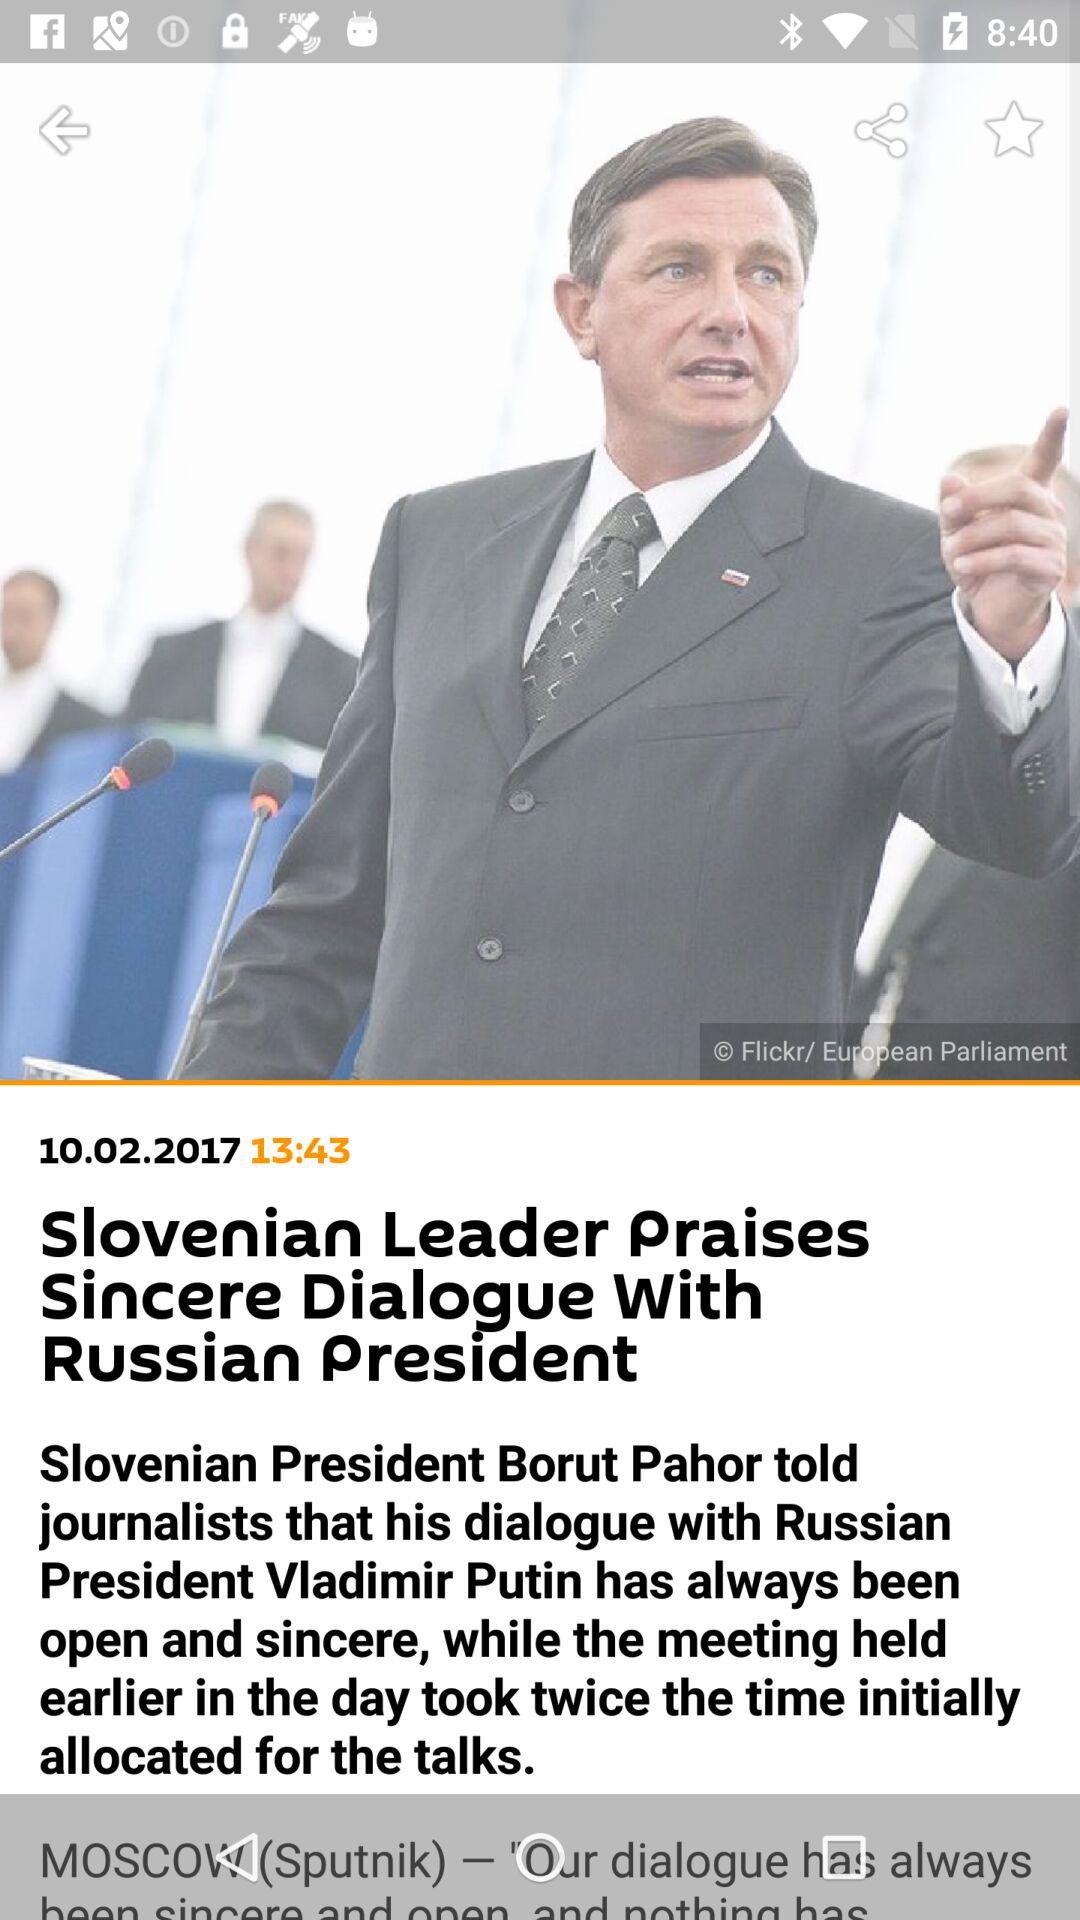What is the given date? The given date is October 2, 2017. 